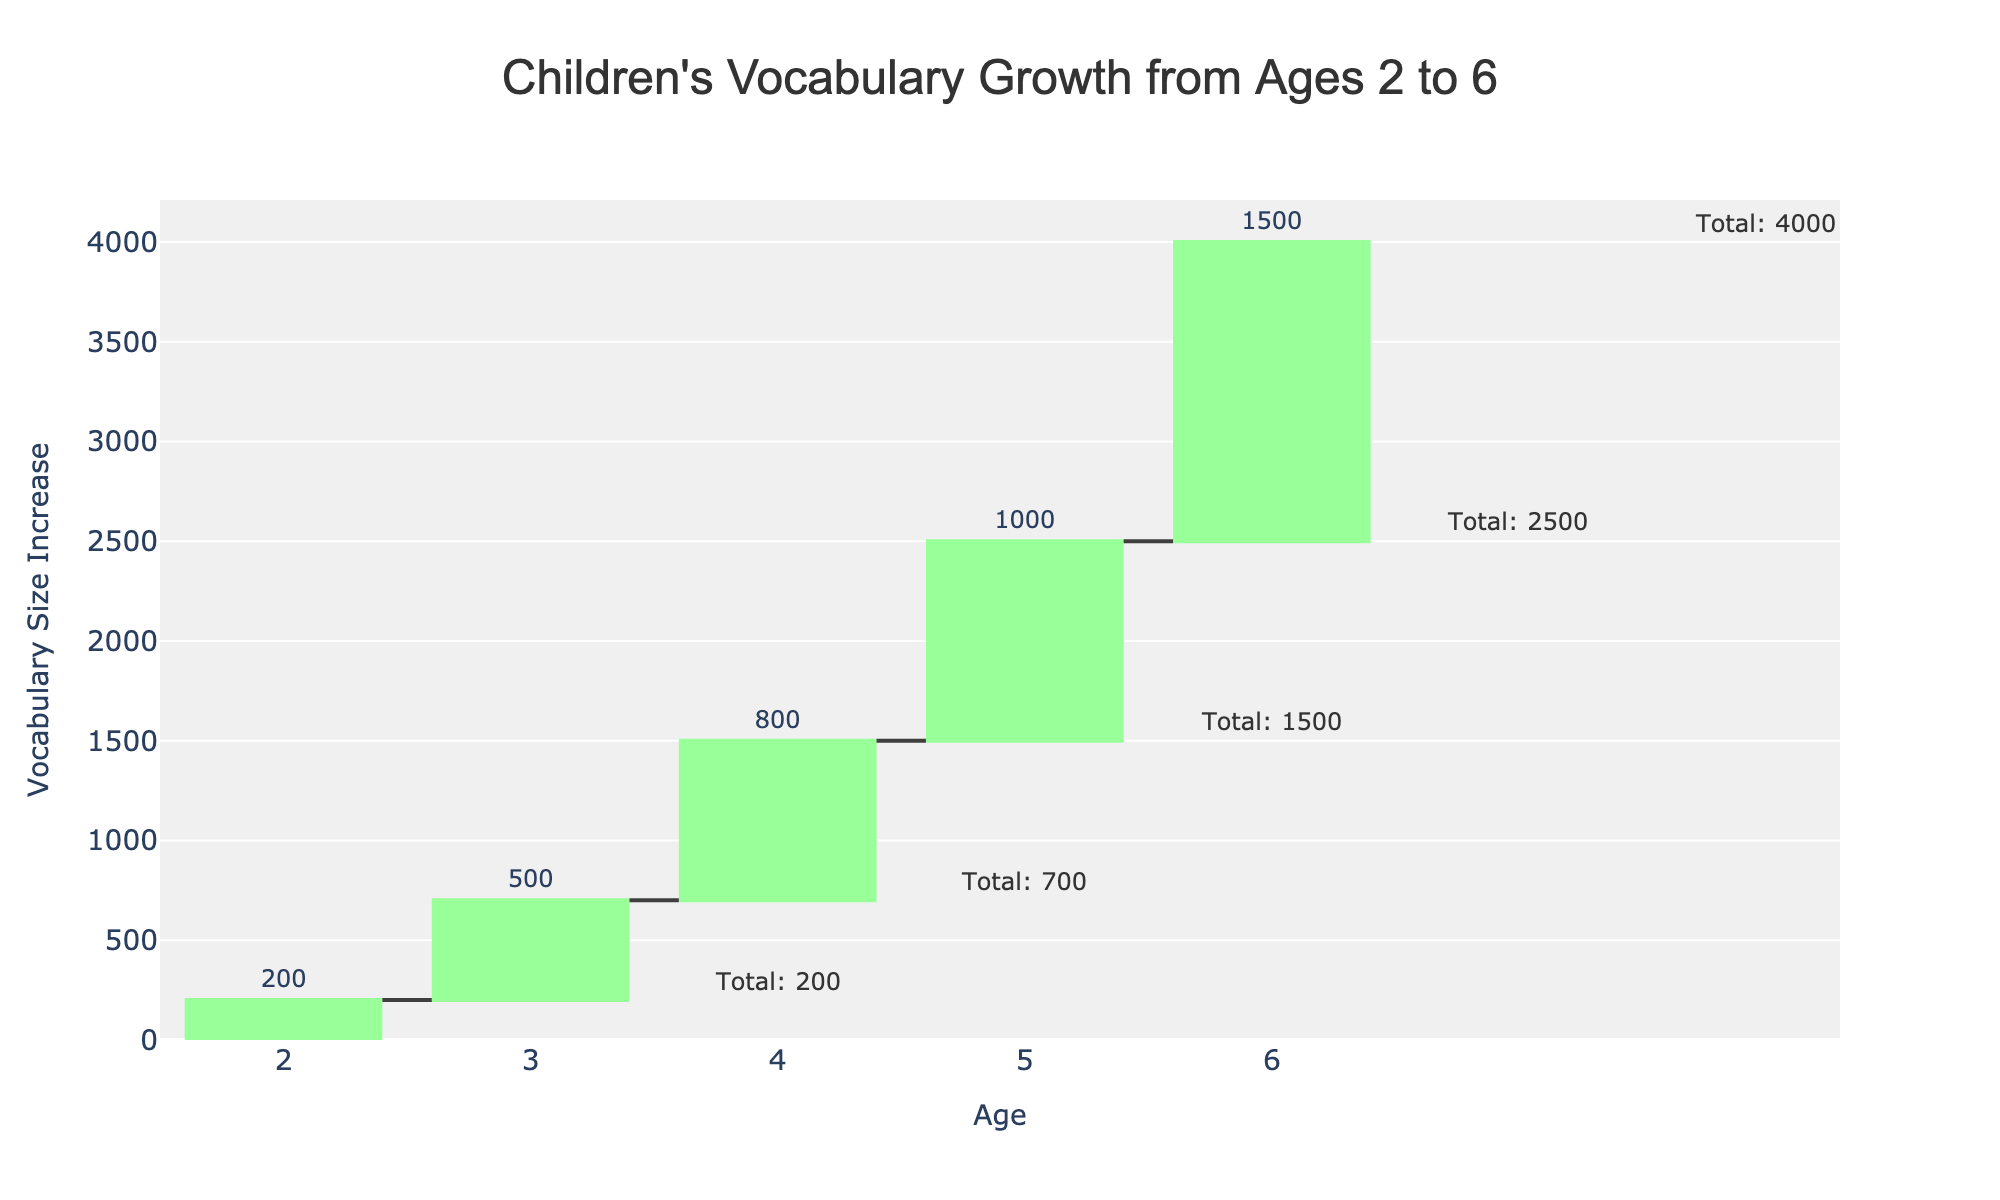What is the title of the figure? The title is clearly displayed at the top of the figure, typically in a larger font and often centered. It provides a description of what the chart is about.
Answer: Children's Vocabulary Growth from Ages 2 to 6 What is the vocabulary size for children at age 4? The vocabulary size is annotated on the figure for age 4. Look for the annotation near the bar corresponding to age 4. It reads "Total: 1500," indicating the total vocabulary size.
Answer: 1500 How much did the vocabulary size increase from age 3 to age 4? To find this, look at the "Change" value for age 4. The chart shows the vocabulary size increases indicated by bars, with "800" annotated as the change for age 4.
Answer: 800 Which age group showed the largest increase in vocabulary size? Compare the "Change" values for all the age groups shown on the waterfall chart. The age group with the tallest bar represents the largest increase. Age 6 has a change value of 1500, which is the highest.
Answer: Age 6 What is the total vocabulary size at age 5? Look for the annotation on the figure corresponding to age 5. It reads "Total: 2500," indicating the total vocabulary size at that age.
Answer: 2500 How many age groups are displayed in this chart? Count the number of bars representing vocabulary increase changes, each corresponding to an age group. There are bars for ages 2, 3, 4, 5, and 6, making a total of 5 age groups.
Answer: 5 What is the average vocabulary size increase per year from ages 2 to 6? First, sum all the "Change" values (200 + 500 + 800 + 1000 + 1500 = 4000). Then divide by the number of increments (5). The calculation is 4000 / 5 = 800.
Answer: 800 By how much does the vocabulary size increase from age 2 to age 6? Sum up the "Change" values from ages 2 to 6. The changes are 200, 500, 800, 1000, and 1500. The total increase is 200 + 500 + 800 + 1000 + 1500 = 4000.
Answer: 4000 Compare the vocabulary size increase between ages 4 and 5. Which is greater, and by how much? The "Change" value for age 4 is 800, and for age 5, it is 1000. Subtract the smaller value from the larger one: 1000 - 800 = 200. The increase is greater at age 5 by 200.
Answer: Age 5, by 200 How does the vocabulary size growth pattern change over the ages from 2 to 6? Observe the increasing heights of the bars. The vocabulary size increase is initially smaller (200 at age 2) and grows progressively larger, reaching the highest increase at age 6 (1500). This indicates an accelerating growth in vocabulary size as children get older.
Answer: Accelerates over time 